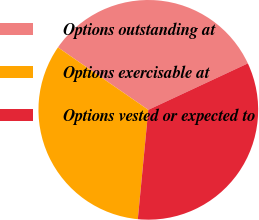<chart> <loc_0><loc_0><loc_500><loc_500><pie_chart><fcel>Options outstanding at<fcel>Options exercisable at<fcel>Options vested or expected to<nl><fcel>33.42%<fcel>33.1%<fcel>33.47%<nl></chart> 